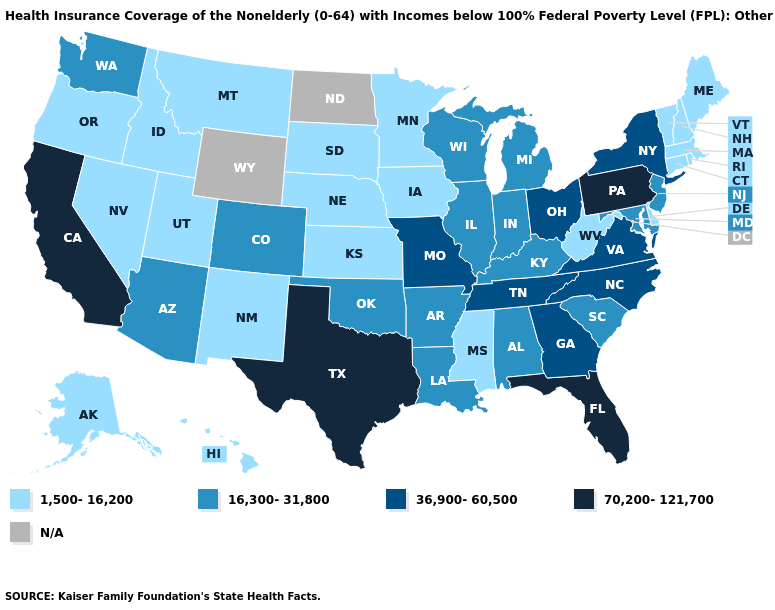What is the value of Florida?
Answer briefly. 70,200-121,700. Does the map have missing data?
Quick response, please. Yes. What is the lowest value in the USA?
Keep it brief. 1,500-16,200. Does the first symbol in the legend represent the smallest category?
Short answer required. Yes. Among the states that border Utah , does New Mexico have the lowest value?
Be succinct. Yes. Does Minnesota have the highest value in the USA?
Keep it brief. No. Which states have the lowest value in the MidWest?
Quick response, please. Iowa, Kansas, Minnesota, Nebraska, South Dakota. What is the lowest value in the USA?
Keep it brief. 1,500-16,200. Which states have the lowest value in the USA?
Answer briefly. Alaska, Connecticut, Delaware, Hawaii, Idaho, Iowa, Kansas, Maine, Massachusetts, Minnesota, Mississippi, Montana, Nebraska, Nevada, New Hampshire, New Mexico, Oregon, Rhode Island, South Dakota, Utah, Vermont, West Virginia. What is the value of California?
Concise answer only. 70,200-121,700. What is the value of Alabama?
Keep it brief. 16,300-31,800. Is the legend a continuous bar?
Be succinct. No. What is the lowest value in the USA?
Concise answer only. 1,500-16,200. Does the first symbol in the legend represent the smallest category?
Quick response, please. Yes. 